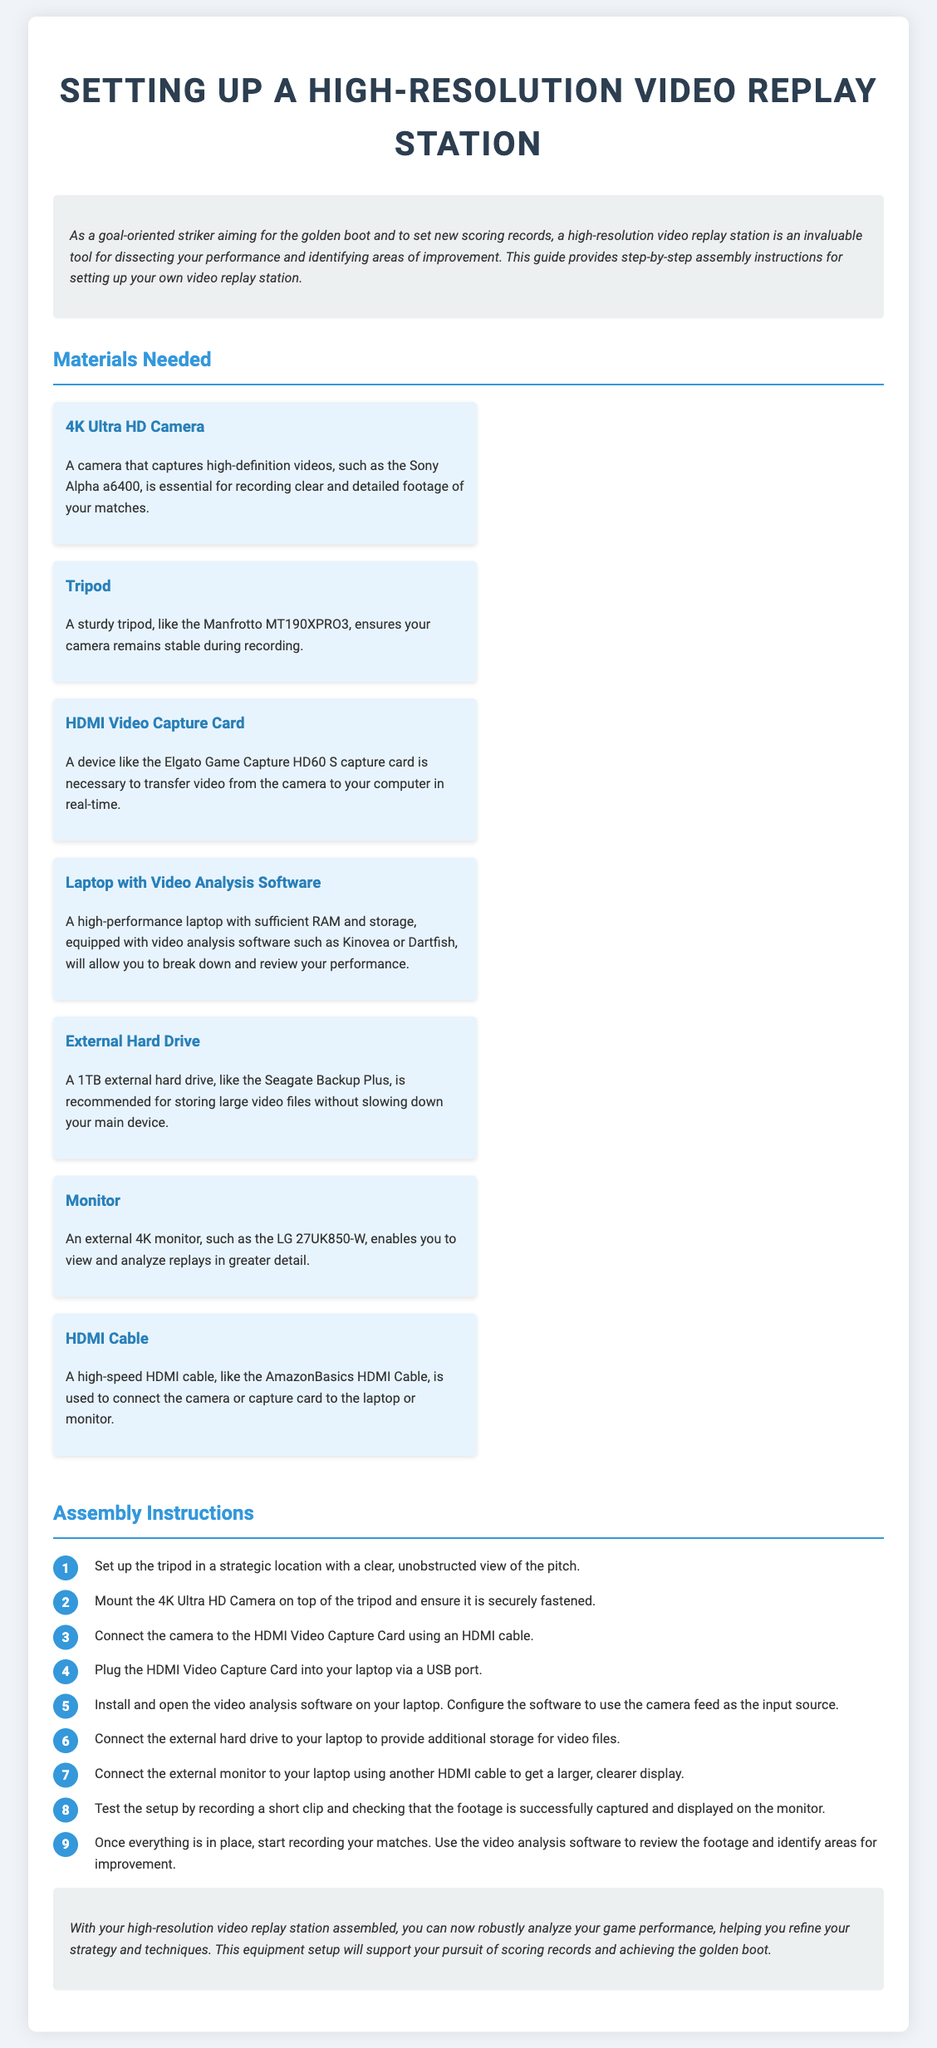What is the primary purpose of the high-resolution video replay station? The primary purpose is to dissect performance and identify areas of improvement.
Answer: Dissecting performance How many materials are listed for setting up the station? The materials section lists seven different items required for the setup.
Answer: Seven What type of camera is recommended? The document specifically mentions a 4K Ultra HD Camera, like the Sony Alpha a6400.
Answer: 4K Ultra HD Camera What should be installed on the laptop for video analysis? The laptop should have video analysis software such as Kinovea or Dartfish.
Answer: Kinovea or Dartfish What is the last instruction for testing the setup? The last instruction is to start recording matches and review the footage for improvement.
Answer: Start recording matches What does the external monitor help with? The external monitor enables viewing and analyzing replays in greater detail.
Answer: Greater detail What device is used to connect the camera to the laptop? The HDMI Video Capture Card is the device used for this connection.
Answer: HDMI Video Capture Card What is the recommended storage capacity for the external hard drive? The document recommends a 1TB external hard drive for storing video files.
Answer: 1TB 